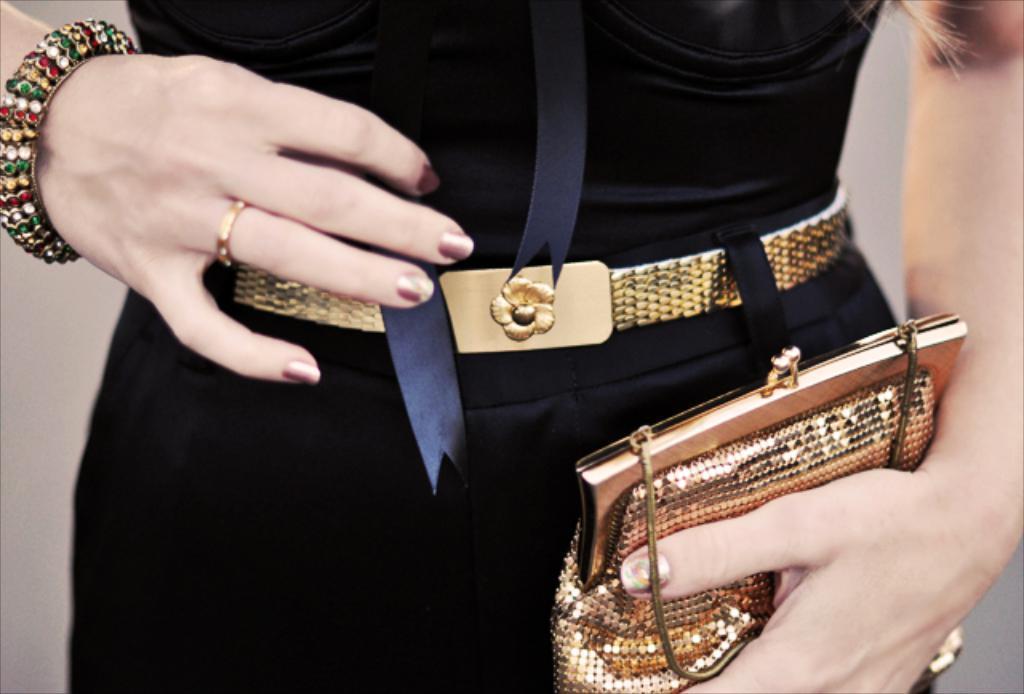Describe this image in one or two sentences. In this picture we can see a women wearing a bangle and she is holding a purse in her hands. 